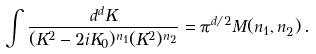<formula> <loc_0><loc_0><loc_500><loc_500>\int \frac { d ^ { d } K } { ( K ^ { 2 } - 2 i K _ { 0 } ) ^ { n _ { 1 } } ( K ^ { 2 } ) ^ { n _ { 2 } } } = \pi ^ { d / 2 } M ( n _ { 1 } , n _ { 2 } ) \, .</formula> 